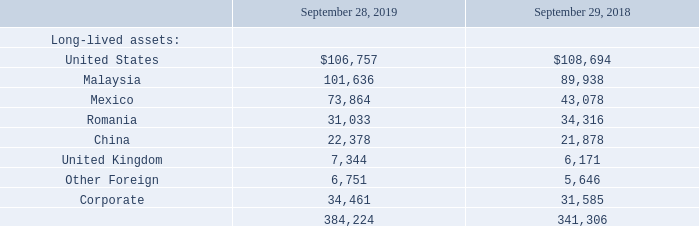11. Reportable Segments, Geographic Information and Major Customers
Reportable segments are defined as components of an enterprise about which separate financial information is available that is evaluated regularly by the chief
operating decision maker, or group, in assessing performance and allocating resources. The Company uses an internal management reporting system, which
provides important financial data to evaluate performance and allocate the Company’s resources on a regional basis. Net sales for the segments are attributed to the
region in which the product is manufactured or the service is performed. The services provided, manufacturing processes used, class of customers serviced and
order fulfillment processes used are similar and generally interchangeable across the segments. A segment’s performance is evaluated based upon its operating
income (loss). A segment’s operating income (loss) includes its net sales less cost of sales and selling and administrative expenses, but excludes corporate and
other expenses. Corporate and other expenses primarily represent corporate selling and administrative expenses, and restructuring costs and other charges, if any, such as the $1.7 million of restructuring costs in
fiscal 2019 and the $13.5 million one-time employee bonus paid to full-time, non-executive employees during fiscal 2018 due to the Company's ability to access
overseas cash as a result of Tax Reform (the "one-time employee bonus"). These costs are not allocated to the segments, as management excludes such costs when
assessing the performance of the segments. Inter-segment transactions are generally recorded at amounts that approximate arm’s length transactions. The
accounting policies for the segments are the same as for the Company taken as a whole.
The following information is provided in accordance with the required segment disclosures for fiscal 2019, 2018 and 2017. Net sales were based on the Company’s location providing the product or service (in thousands):
As the Company operates flexible manufacturing facilities and processes designed to accommodate customers with multiple product lines and configurations, it is impracticable to report net sales for individual products or services or groups of similar products and services.
Long-lived assets as of September 28, 2019 and September 29, 2018 exclude other long-term assets, deferred income tax assets and intangible assets, which totaled $78.4 million and $74.2 million, respectively.
Which years does the table provide information for the company's long-lived assest? 2019, 2018. What was the amount of long-lived assets in United States in 2019?
Answer scale should be: thousand. 106,757. What was the amount of long-lived assets in Mexico in 2018?
Answer scale should be: thousand. 43,078. Which countries had long-lived assets that exceed $100,000 thousand in 2019? (United States:106,757),(Malaysia:101,636)
Answer: united states, malaysia. What was the change in the long-lived assets in China between 2018 and 2019?
Answer scale should be: thousand. 22,378-21,878
Answer: 500. What was the percentage change in the total long-lived assets across all countries between 2018 and 2019?
Answer scale should be: percent. (384,224-341,306)/341,306
Answer: 12.57. 